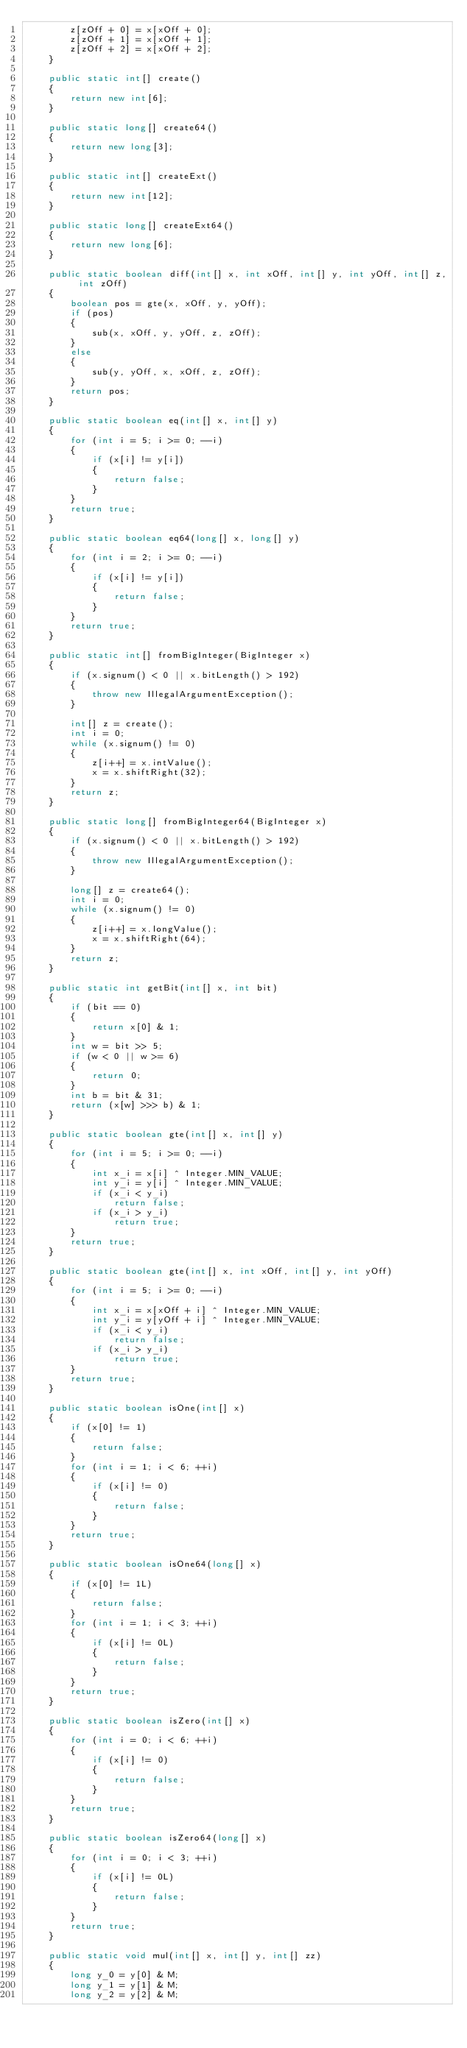Convert code to text. <code><loc_0><loc_0><loc_500><loc_500><_Java_>        z[zOff + 0] = x[xOff + 0];
        z[zOff + 1] = x[xOff + 1];
        z[zOff + 2] = x[xOff + 2];
    }

    public static int[] create()
    {
        return new int[6];
    }

    public static long[] create64()
    {
        return new long[3];
    }

    public static int[] createExt()
    {
        return new int[12];
    }

    public static long[] createExt64()
    {
        return new long[6];
    }

    public static boolean diff(int[] x, int xOff, int[] y, int yOff, int[] z, int zOff)
    {
        boolean pos = gte(x, xOff, y, yOff);
        if (pos)
        {
            sub(x, xOff, y, yOff, z, zOff);
        }
        else
        {
            sub(y, yOff, x, xOff, z, zOff);
        }
        return pos;
    }

    public static boolean eq(int[] x, int[] y)
    {
        for (int i = 5; i >= 0; --i)
        {
            if (x[i] != y[i])
            {
                return false;
            }
        }
        return true;
    }

    public static boolean eq64(long[] x, long[] y)
    {
        for (int i = 2; i >= 0; --i)
        {
            if (x[i] != y[i])
            {
                return false;
            }
        }
        return true;
    }

    public static int[] fromBigInteger(BigInteger x)
    {
        if (x.signum() < 0 || x.bitLength() > 192)
        {
            throw new IllegalArgumentException();
        }

        int[] z = create();
        int i = 0;
        while (x.signum() != 0)
        {
            z[i++] = x.intValue();
            x = x.shiftRight(32);
        }
        return z;
    }

    public static long[] fromBigInteger64(BigInteger x)
    {
        if (x.signum() < 0 || x.bitLength() > 192)
        {
            throw new IllegalArgumentException();
        }

        long[] z = create64();
        int i = 0;
        while (x.signum() != 0)
        {
            z[i++] = x.longValue();
            x = x.shiftRight(64);
        }
        return z;
    }

    public static int getBit(int[] x, int bit)
    {
        if (bit == 0)
        {
            return x[0] & 1;
        }
        int w = bit >> 5;
        if (w < 0 || w >= 6)
        {
            return 0;
        }
        int b = bit & 31;
        return (x[w] >>> b) & 1;
    }

    public static boolean gte(int[] x, int[] y)
    {
        for (int i = 5; i >= 0; --i)
        {
            int x_i = x[i] ^ Integer.MIN_VALUE;
            int y_i = y[i] ^ Integer.MIN_VALUE;
            if (x_i < y_i)
                return false;
            if (x_i > y_i)
                return true;
        }
        return true;
    }

    public static boolean gte(int[] x, int xOff, int[] y, int yOff)
    {
        for (int i = 5; i >= 0; --i)
        {
            int x_i = x[xOff + i] ^ Integer.MIN_VALUE;
            int y_i = y[yOff + i] ^ Integer.MIN_VALUE;
            if (x_i < y_i)
                return false;
            if (x_i > y_i)
                return true;
        }
        return true;
    }

    public static boolean isOne(int[] x)
    {
        if (x[0] != 1)
        {
            return false;
        }
        for (int i = 1; i < 6; ++i)
        {
            if (x[i] != 0)
            {
                return false;
            }
        }
        return true;
    }

    public static boolean isOne64(long[] x)
    {
        if (x[0] != 1L)
        {
            return false;
        }
        for (int i = 1; i < 3; ++i)
        {
            if (x[i] != 0L)
            {
                return false;
            }
        }
        return true;
    }

    public static boolean isZero(int[] x)
    {
        for (int i = 0; i < 6; ++i)
        {
            if (x[i] != 0)
            {
                return false;
            }
        }
        return true;
    }

    public static boolean isZero64(long[] x)
    {
        for (int i = 0; i < 3; ++i)
        {
            if (x[i] != 0L)
            {
                return false;
            }
        }
        return true;
    }

    public static void mul(int[] x, int[] y, int[] zz)
    {
        long y_0 = y[0] & M;
        long y_1 = y[1] & M;
        long y_2 = y[2] & M;</code> 